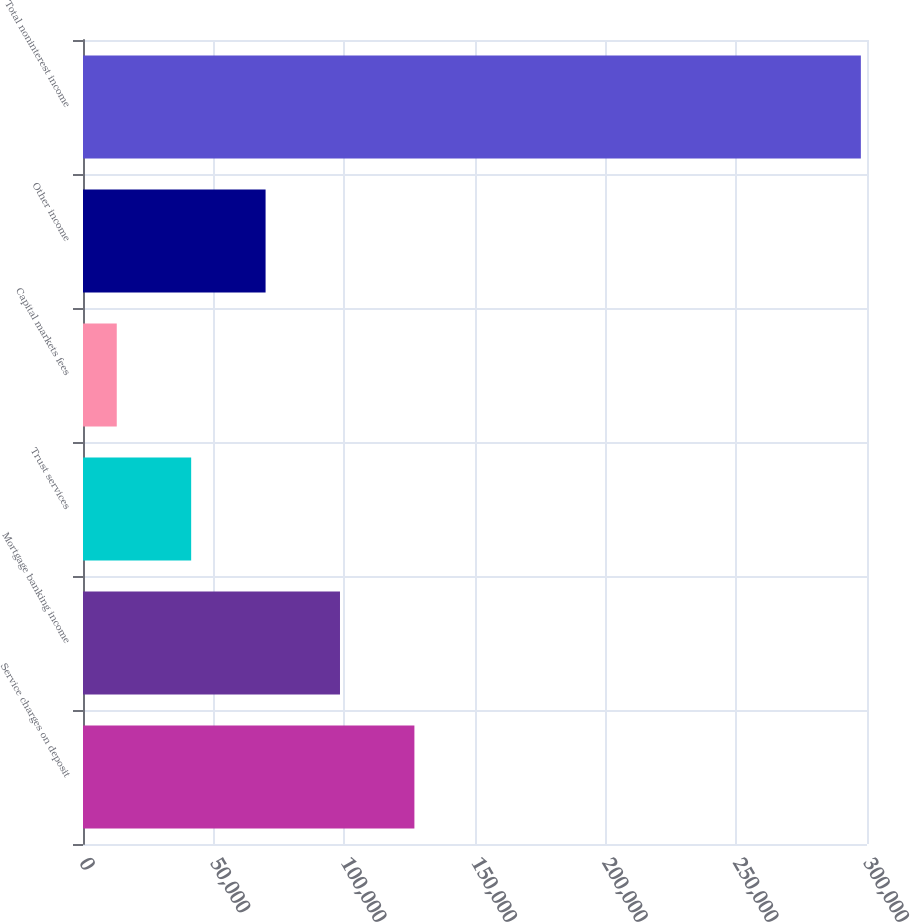<chart> <loc_0><loc_0><loc_500><loc_500><bar_chart><fcel>Service charges on deposit<fcel>Mortgage banking income<fcel>Trust services<fcel>Capital markets fees<fcel>Other income<fcel>Total noninterest income<nl><fcel>126811<fcel>98337.9<fcel>41391.3<fcel>12918<fcel>69864.6<fcel>297651<nl></chart> 